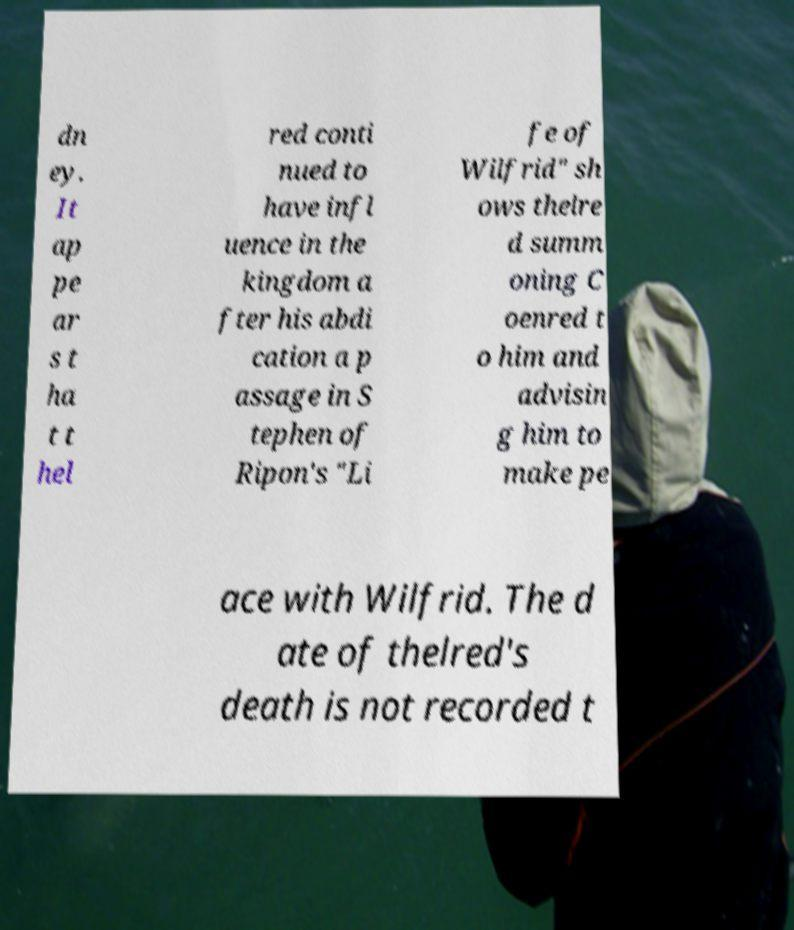Could you assist in decoding the text presented in this image and type it out clearly? dn ey. It ap pe ar s t ha t t hel red conti nued to have infl uence in the kingdom a fter his abdi cation a p assage in S tephen of Ripon's "Li fe of Wilfrid" sh ows thelre d summ oning C oenred t o him and advisin g him to make pe ace with Wilfrid. The d ate of thelred's death is not recorded t 